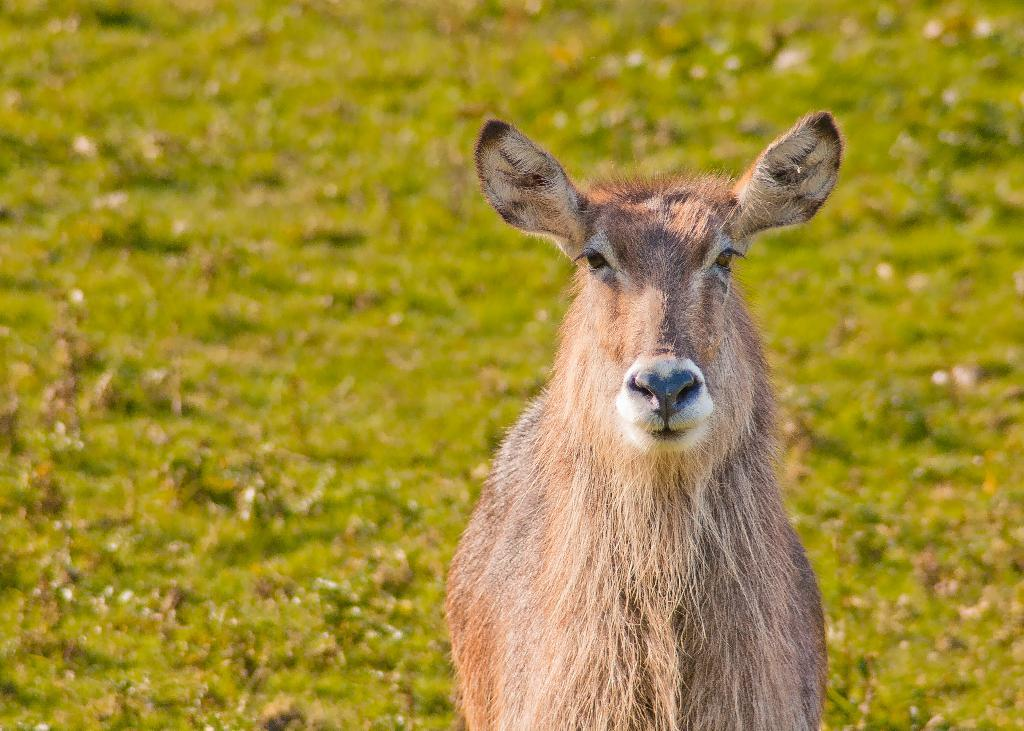What type of animal is present in the image? There is a deer in the image. What type of sea creature can be seen on the stage in the image? There is no sea creature or stage present in the image; it features a deer. 